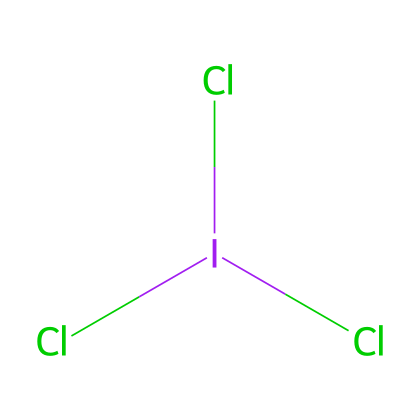What is the central atom in iodine trichloride? The structure indicates that iodine is the central atom, as it is surrounded by three chlorine atoms.
Answer: iodine How many chlorine atoms are present in iodine trichloride? Counting the chlorine atoms in the structure shows there are three chlorine atoms attached to the central iodine atom.
Answer: 3 What type of hybridization is likely present in iodine trichloride? Given that iodine is surrounded by three chlorine atoms and has a lone pair, the hybridization is likely sp³d, indicating it has five regions of electron density.
Answer: sp³d What is the oxidation state of iodine in iodine trichloride? The oxidation state of iodine can be calculated by assigning -1 to each chlorine atom (the typical oxidation state for halogens). Since there are three chlorines, it results in an oxidation state of +3 for iodine.
Answer: +3 Is iodine trichloride a hypervalent compound? Iodine trichloride is a hypervalent compound because iodine can exceed the octet rule, holding more than eight electrons in its valence shell due to its larger atomic size.
Answer: yes 